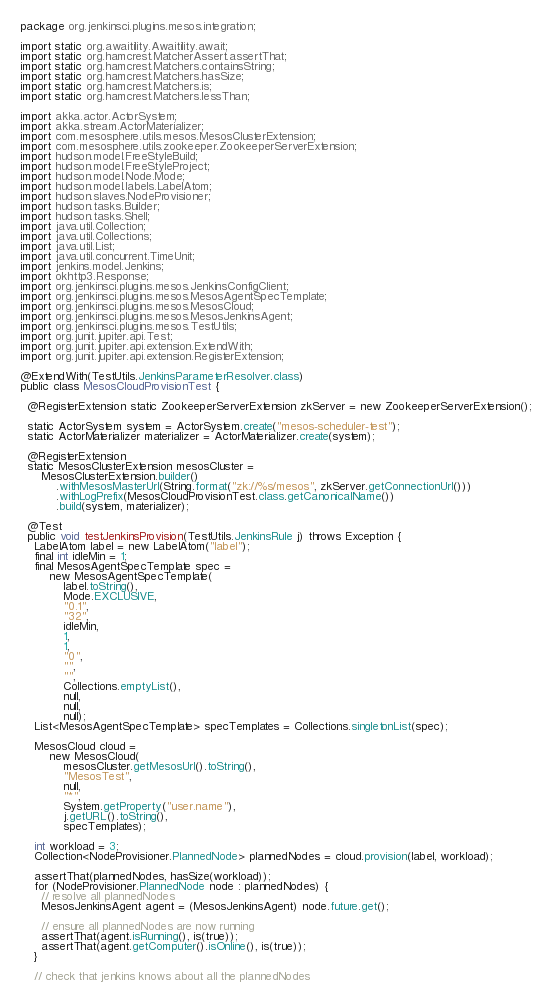Convert code to text. <code><loc_0><loc_0><loc_500><loc_500><_Java_>package org.jenkinsci.plugins.mesos.integration;

import static org.awaitility.Awaitility.await;
import static org.hamcrest.MatcherAssert.assertThat;
import static org.hamcrest.Matchers.containsString;
import static org.hamcrest.Matchers.hasSize;
import static org.hamcrest.Matchers.is;
import static org.hamcrest.Matchers.lessThan;

import akka.actor.ActorSystem;
import akka.stream.ActorMaterializer;
import com.mesosphere.utils.mesos.MesosClusterExtension;
import com.mesosphere.utils.zookeeper.ZookeeperServerExtension;
import hudson.model.FreeStyleBuild;
import hudson.model.FreeStyleProject;
import hudson.model.Node.Mode;
import hudson.model.labels.LabelAtom;
import hudson.slaves.NodeProvisioner;
import hudson.tasks.Builder;
import hudson.tasks.Shell;
import java.util.Collection;
import java.util.Collections;
import java.util.List;
import java.util.concurrent.TimeUnit;
import jenkins.model.Jenkins;
import okhttp3.Response;
import org.jenkinsci.plugins.mesos.JenkinsConfigClient;
import org.jenkinsci.plugins.mesos.MesosAgentSpecTemplate;
import org.jenkinsci.plugins.mesos.MesosCloud;
import org.jenkinsci.plugins.mesos.MesosJenkinsAgent;
import org.jenkinsci.plugins.mesos.TestUtils;
import org.junit.jupiter.api.Test;
import org.junit.jupiter.api.extension.ExtendWith;
import org.junit.jupiter.api.extension.RegisterExtension;

@ExtendWith(TestUtils.JenkinsParameterResolver.class)
public class MesosCloudProvisionTest {

  @RegisterExtension static ZookeeperServerExtension zkServer = new ZookeeperServerExtension();

  static ActorSystem system = ActorSystem.create("mesos-scheduler-test");
  static ActorMaterializer materializer = ActorMaterializer.create(system);

  @RegisterExtension
  static MesosClusterExtension mesosCluster =
      MesosClusterExtension.builder()
          .withMesosMasterUrl(String.format("zk://%s/mesos", zkServer.getConnectionUrl()))
          .withLogPrefix(MesosCloudProvisionTest.class.getCanonicalName())
          .build(system, materializer);

  @Test
  public void testJenkinsProvision(TestUtils.JenkinsRule j) throws Exception {
    LabelAtom label = new LabelAtom("label");
    final int idleMin = 1;
    final MesosAgentSpecTemplate spec =
        new MesosAgentSpecTemplate(
            label.toString(),
            Mode.EXCLUSIVE,
            "0.1",
            "32",
            idleMin,
            1,
            1,
            "0",
            "",
            "",
            Collections.emptyList(),
            null,
            null,
            null);
    List<MesosAgentSpecTemplate> specTemplates = Collections.singletonList(spec);

    MesosCloud cloud =
        new MesosCloud(
            mesosCluster.getMesosUrl().toString(),
            "MesosTest",
            null,
            "*",
            System.getProperty("user.name"),
            j.getURL().toString(),
            specTemplates);

    int workload = 3;
    Collection<NodeProvisioner.PlannedNode> plannedNodes = cloud.provision(label, workload);

    assertThat(plannedNodes, hasSize(workload));
    for (NodeProvisioner.PlannedNode node : plannedNodes) {
      // resolve all plannedNodes
      MesosJenkinsAgent agent = (MesosJenkinsAgent) node.future.get();

      // ensure all plannedNodes are now running
      assertThat(agent.isRunning(), is(true));
      assertThat(agent.getComputer().isOnline(), is(true));
    }

    // check that jenkins knows about all the plannedNodes</code> 